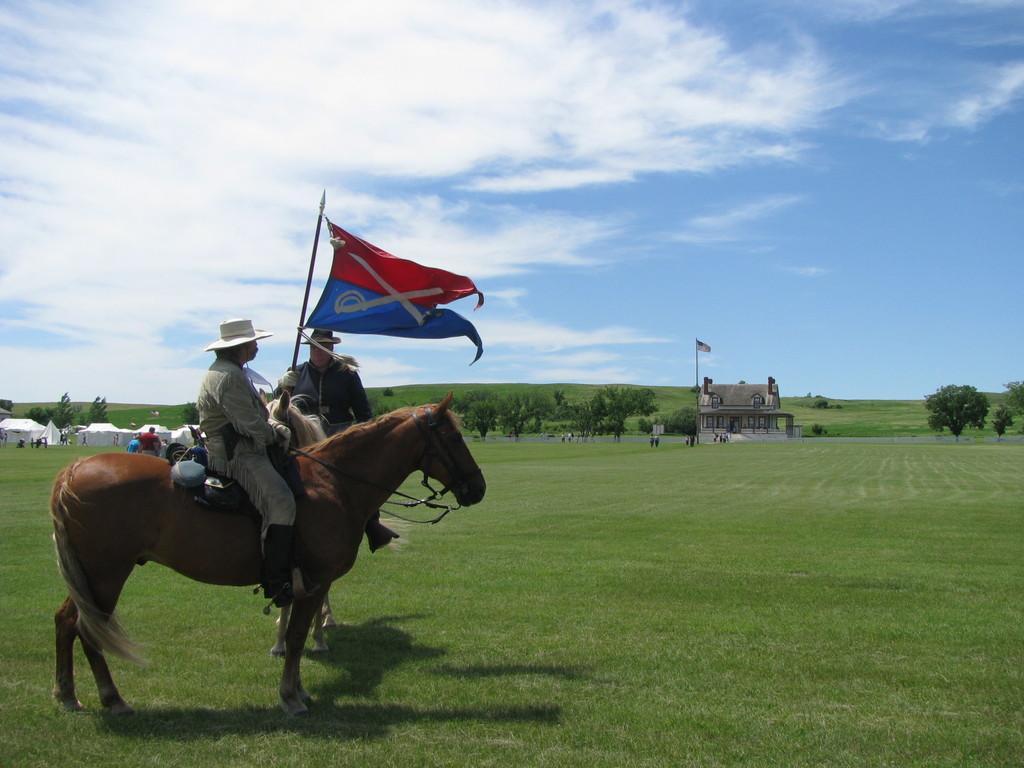Describe this image in one or two sentences. This picture is taken from outside of the city. In this image, on the left side, we can see a man wearing a white color cap is sitting on the horse and holding a collar rope of a horse. On the left side, we can see some text, a group of people, trees, plants. In the middle of the image, we can see a house, flag. On the right side, we can see some trees and plants. In the background, we can see some trees, plants. At the top, we can see a sky which is cloudy, at the bottom, we can see some plants and a grass. 